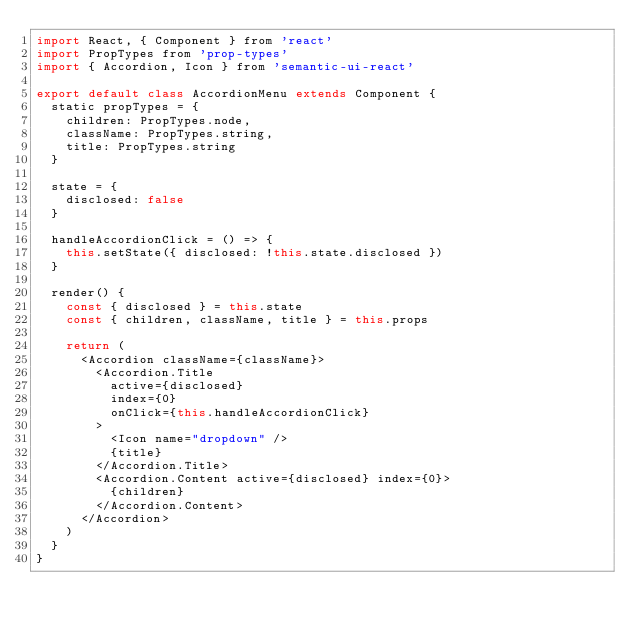<code> <loc_0><loc_0><loc_500><loc_500><_JavaScript_>import React, { Component } from 'react'
import PropTypes from 'prop-types'
import { Accordion, Icon } from 'semantic-ui-react'

export default class AccordionMenu extends Component {
  static propTypes = {
    children: PropTypes.node,
    className: PropTypes.string,
    title: PropTypes.string
  }

  state = {
    disclosed: false
  }

  handleAccordionClick = () => {
    this.setState({ disclosed: !this.state.disclosed })
  }

  render() {
    const { disclosed } = this.state
    const { children, className, title } = this.props

    return (
      <Accordion className={className}>
        <Accordion.Title
          active={disclosed}
          index={0}
          onClick={this.handleAccordionClick}
        >
          <Icon name="dropdown" />
          {title}
        </Accordion.Title>
        <Accordion.Content active={disclosed} index={0}>
          {children}
        </Accordion.Content>
      </Accordion>
    )
  }
}
</code> 